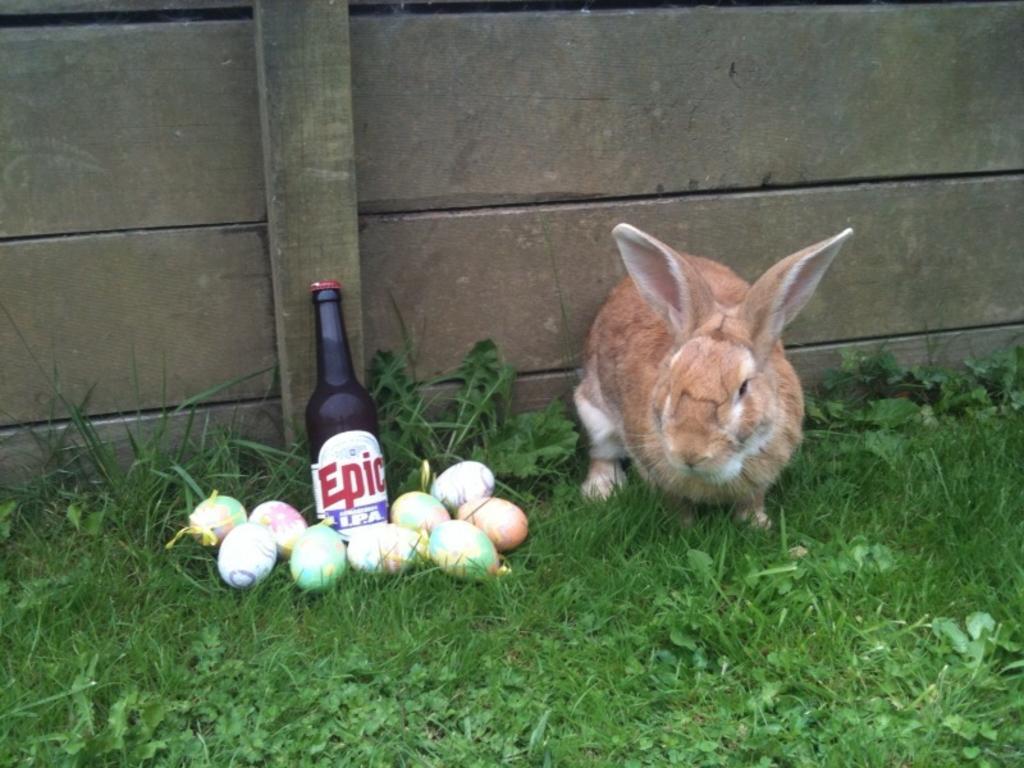Please provide a concise description of this image. In this image we can see brown color rabbit which is on the ground, there are some eggs and bottle also on the ground and at the background of the image there is wall. 